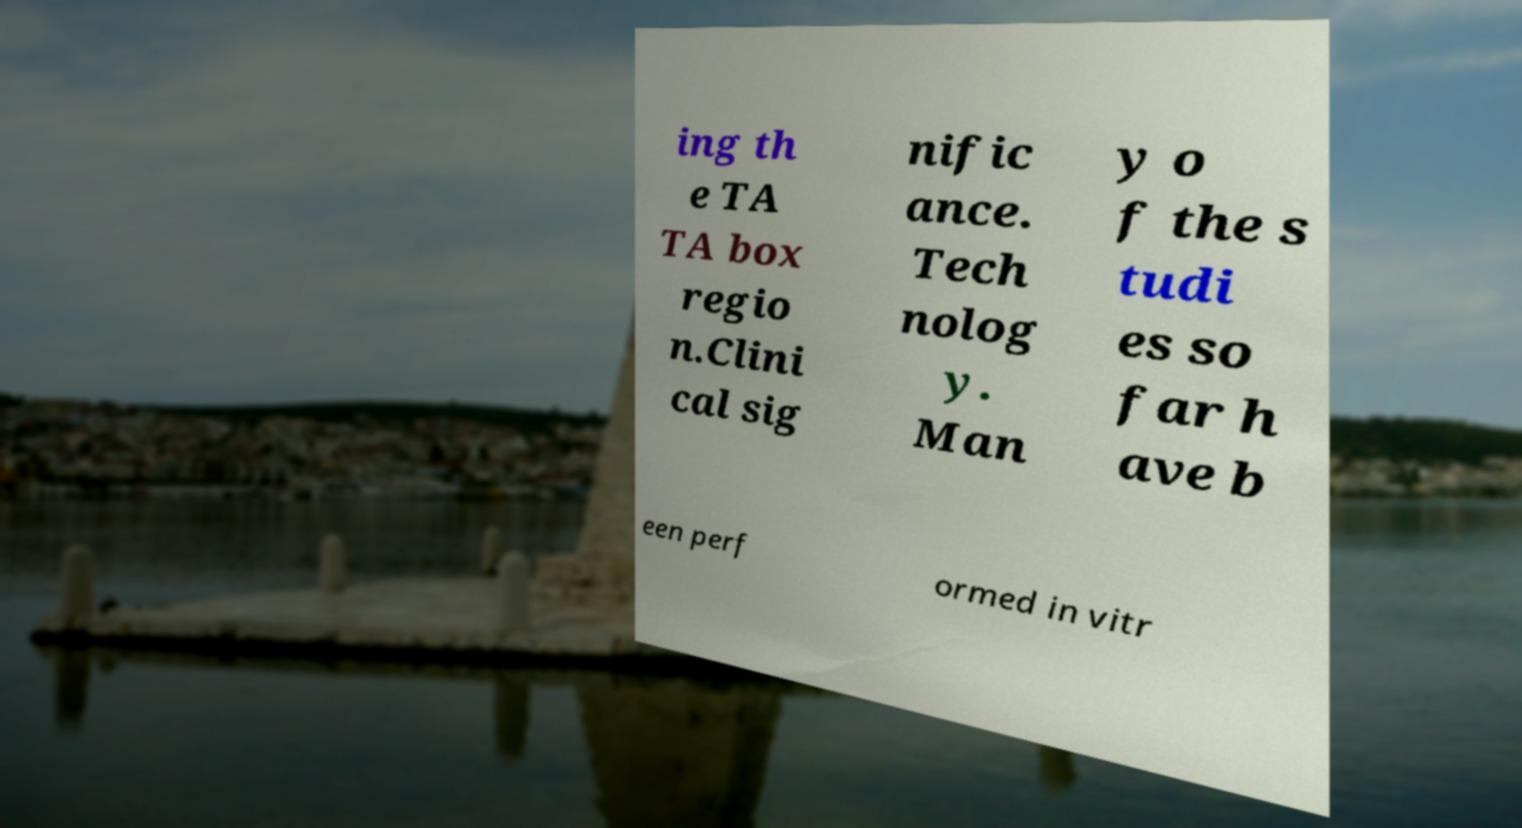For documentation purposes, I need the text within this image transcribed. Could you provide that? ing th e TA TA box regio n.Clini cal sig nific ance. Tech nolog y. Man y o f the s tudi es so far h ave b een perf ormed in vitr 